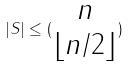<formula> <loc_0><loc_0><loc_500><loc_500>| S | \leq ( \begin{matrix} n \\ \lfloor n / 2 \rfloor \end{matrix} )</formula> 